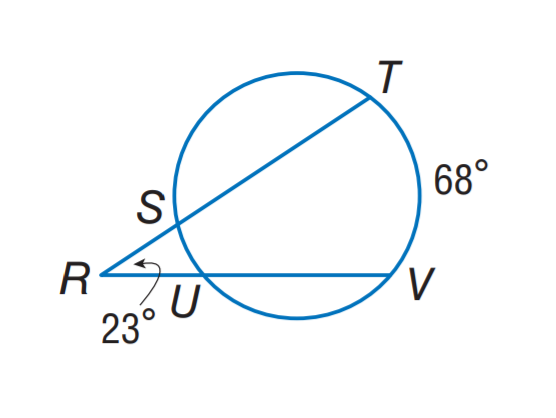Answer the mathemtical geometry problem and directly provide the correct option letter.
Question: Find m \widehat S U.
Choices: A: 22 B: 23 C: 34 D: 68 A 